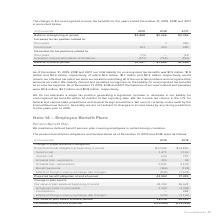According to Adtran's financial document, What was the accumulated benefit obligation in 2019? Based on the financial document, the answer is $43.9 million. Also, What does the table show? pension benefit plan obligations and funded status as of December 31, 2019 and 2018. The document states: "The pension benefit plan obligations and funded status as of December 31, 2019 and 2018, were as follows:..." Also, What was the service cost in 2019? According to the financial document, 1,471 (in thousands). The relevant text states: "Service cost 1,471 1,193..." Also, can you calculate: What was the change in service cost between 2018 and 2019? Based on the calculation: 1,471-1,193, the result is 278 (in thousands). This is based on the information: "Service cost 1,471 1,193 Service cost 1,471 1,193..." The key data points involved are: 1,193, 1,471. Also, can you calculate: What was the change in interest cost between 2018 and 2019? Based on the calculation: 634-727, the result is -93 (in thousands). This is based on the information: "Interest cost 634 727 Interest cost 634 727..." The key data points involved are: 634, 727. Also, can you calculate: What was the percentage change in the fair value of plan assets at end of period between 2018 and 2019? To answer this question, I need to perform calculations using the financial data. The calculation is: (28,016-24,159)/24,159, which equals 15.97 (percentage). This is based on the information: "Fair value of plan assets at end of period 28,016 24,159 Fair value of plan assets at end of period 28,016 24,159..." The key data points involved are: 24,159, 28,016. 